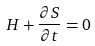<formula> <loc_0><loc_0><loc_500><loc_500>H + \frac { \partial S } { \partial t } = 0</formula> 